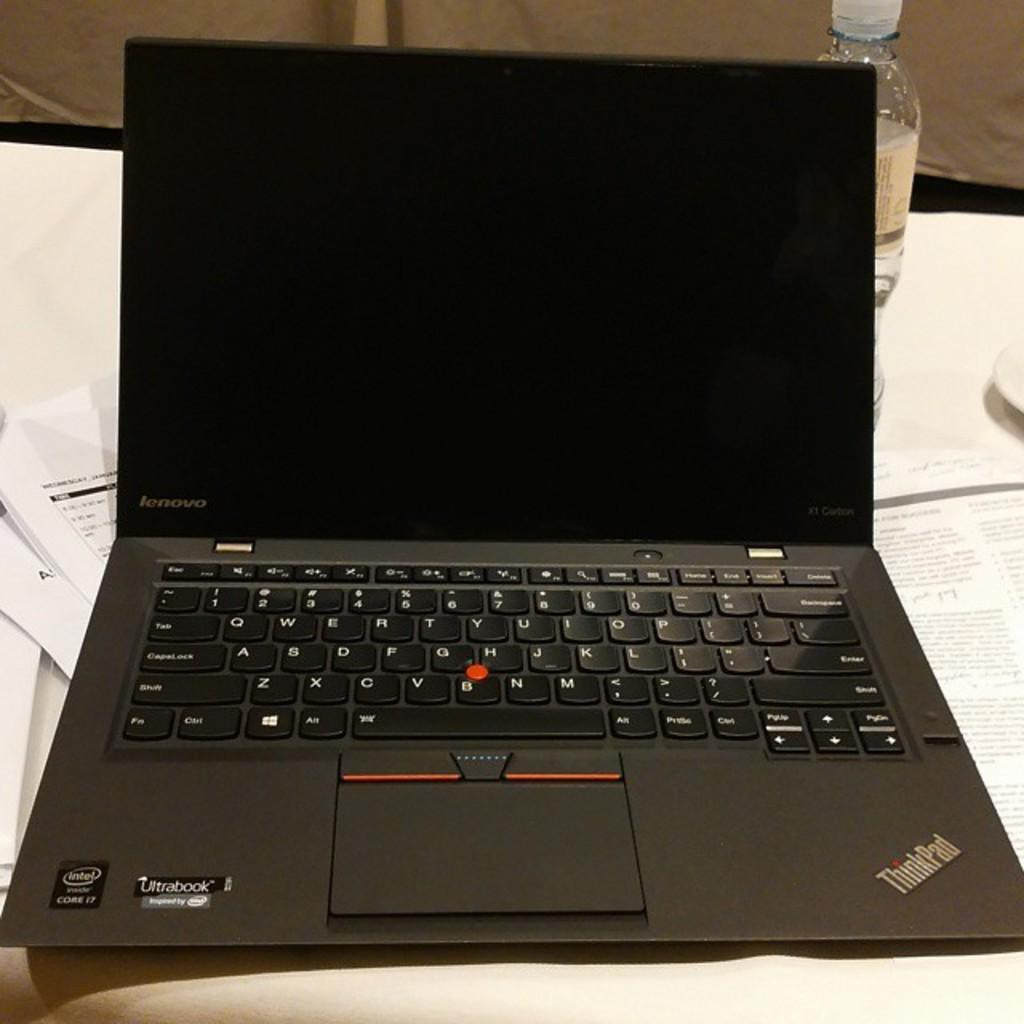<image>
Give a short and clear explanation of the subsequent image. A Lenovo laptop is open on a white table. 